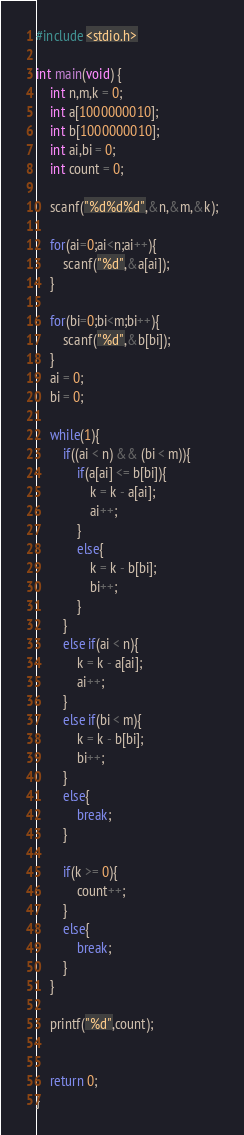<code> <loc_0><loc_0><loc_500><loc_500><_C_>#include <stdio.h>

int main(void) {
	int n,m,k = 0;
	int a[1000000010];
	int b[1000000010];
	int ai,bi = 0;
	int count = 0;
	
	scanf("%d%d%d",&n,&m,&k);
	
	for(ai=0;ai<n;ai++){
		scanf("%d",&a[ai]);
	}
	
	for(bi=0;bi<m;bi++){
		scanf("%d",&b[bi]);
	}
	ai = 0;
	bi = 0;
	
	while(1){
		if((ai < n) && (bi < m)){
			if(a[ai] <= b[bi]){
				k = k - a[ai];
				ai++;
			}
			else{
				k = k - b[bi];
				bi++;
			}
		}
		else if(ai < n){
			k = k - a[ai];
			ai++;
		}
		else if(bi < m){
			k = k - b[bi];
			bi++;
		}
		else{
			break;
		}
		
		if(k >= 0){
			count++;
		}
		else{
			break;
		}
	}
	
	printf("%d",count);
	

	return 0;
}
</code> 